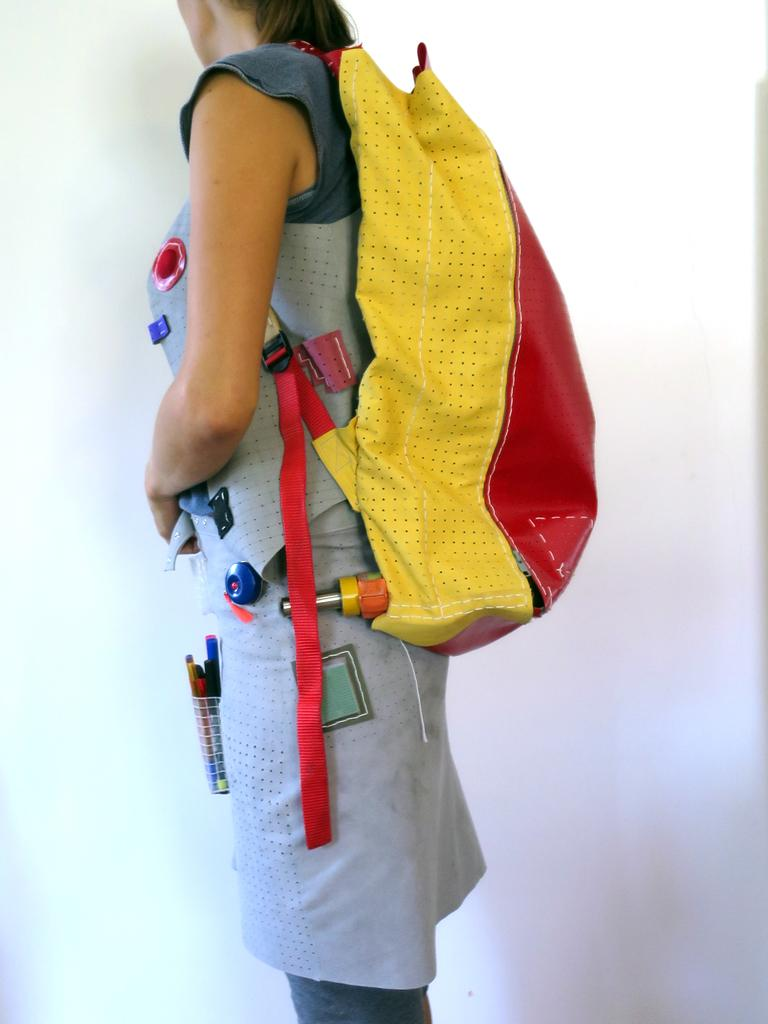Who is the main subject in the image? There is a woman in the center of the image. What is the woman wearing? The woman is wearing a bag. What is the woman holding in her hand? The woman is holding pens. What is the woman's posture in the image? The woman is standing. What can be seen behind the woman in the image? There is a plain white wall in the background of the image. Can you see a cat playing with an apparatus in the image? There is no cat or apparatus present in the image. Is there a rose in the woman's hand in the image? The woman is holding pens, not a rose, in the image. 